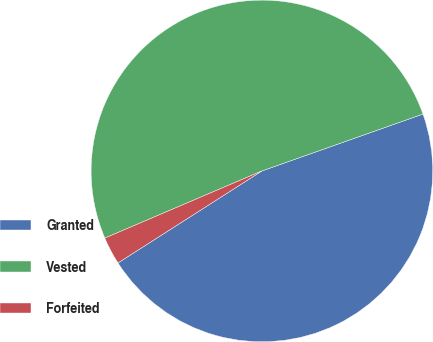<chart> <loc_0><loc_0><loc_500><loc_500><pie_chart><fcel>Granted<fcel>Vested<fcel>Forfeited<nl><fcel>46.36%<fcel>51.03%<fcel>2.62%<nl></chart> 